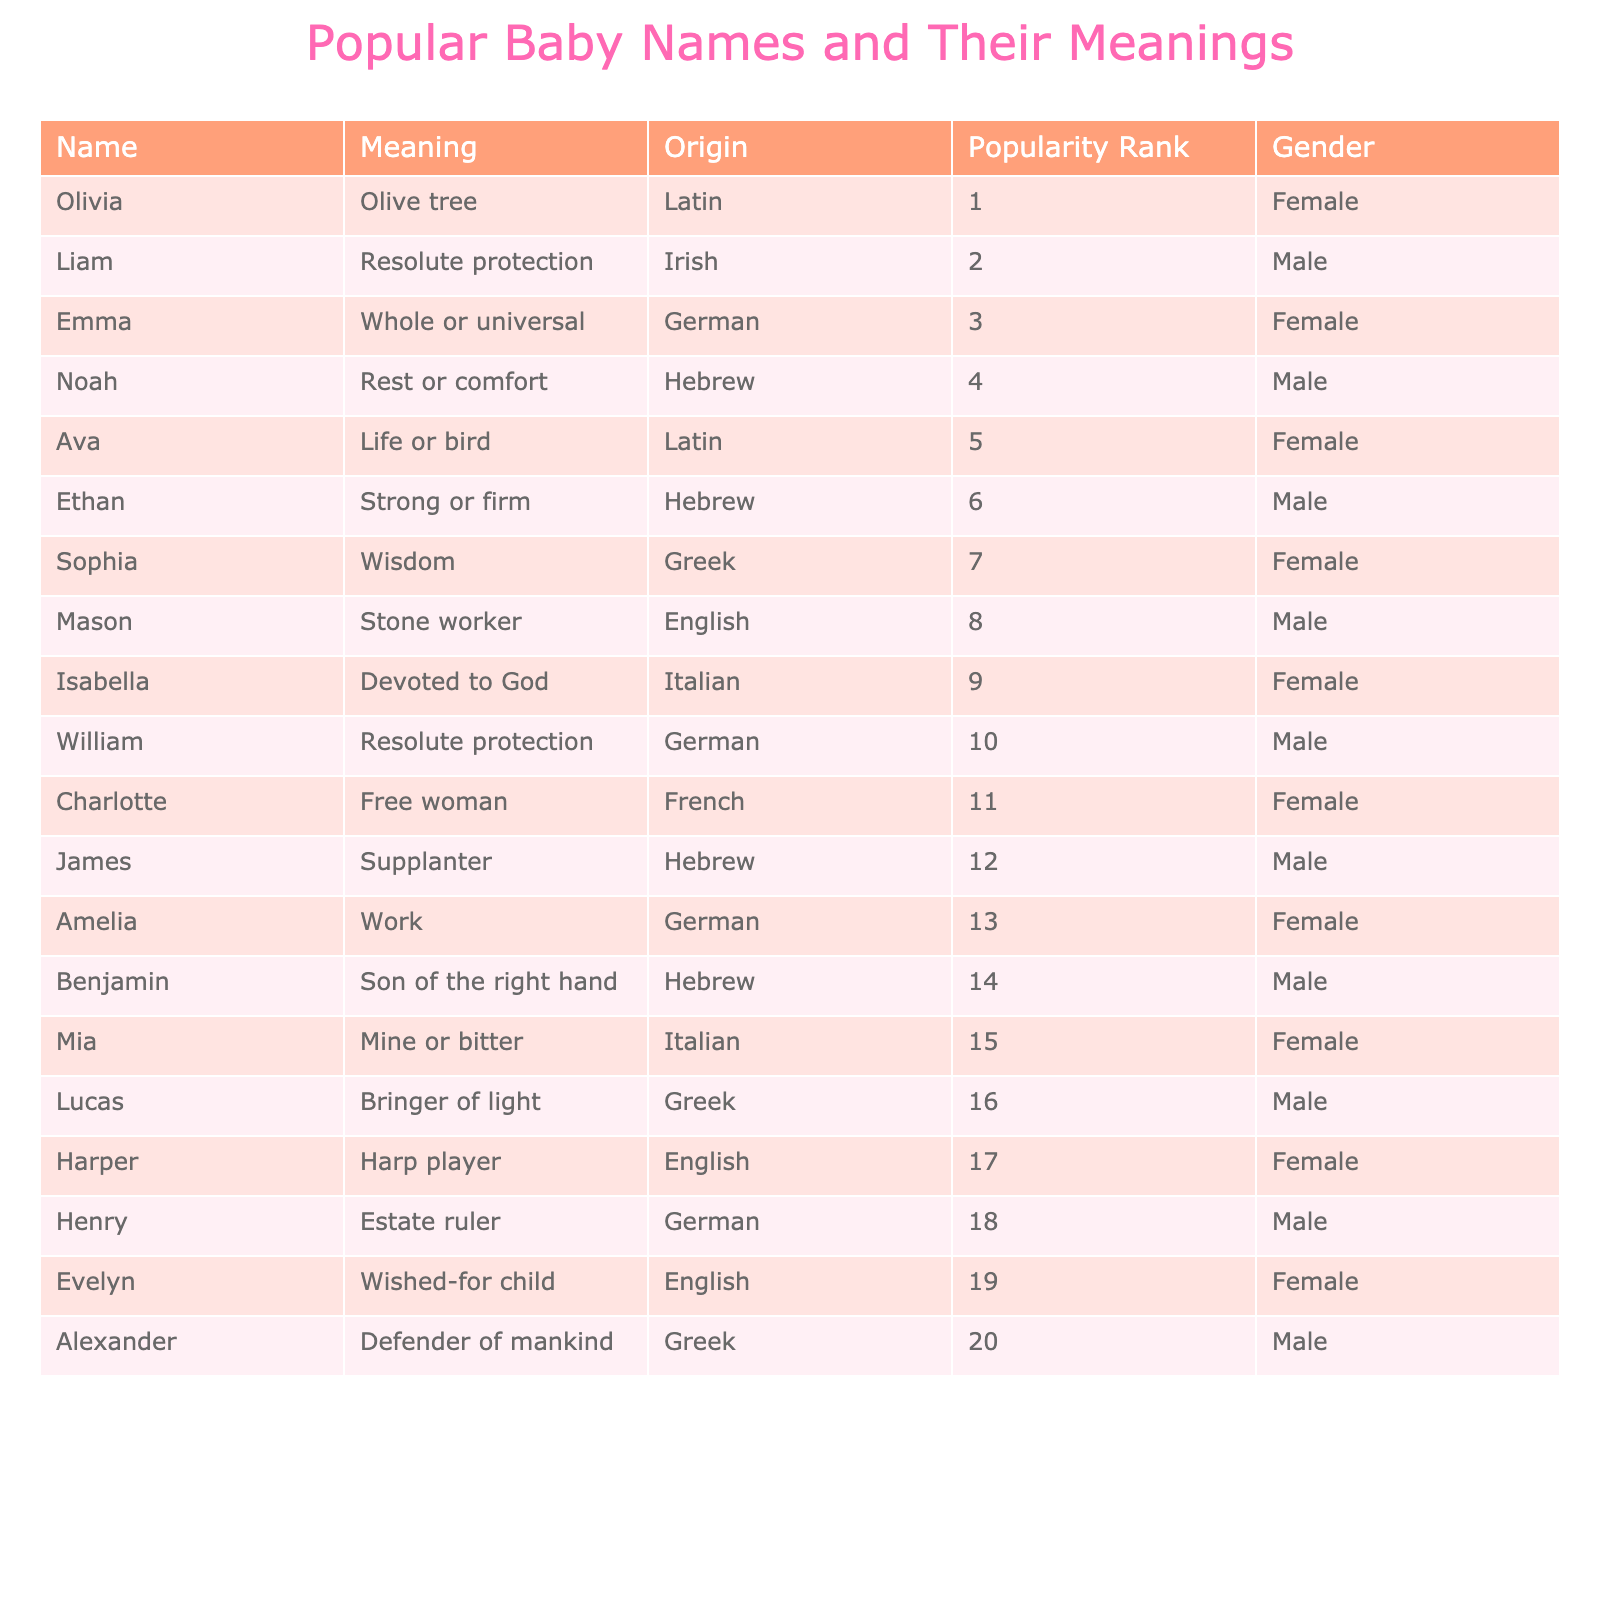What is the most popular baby name for females? The table shows the names and their popularity ranks. Olivia has the rank of 1 and is categorized as female.
Answer: Olivia What name means "rest or comfort"? The table lists the meanings of the names; Noah is associated with "rest or comfort."
Answer: Noah Which name has the origin "Greek" and ranks 20th in popularity? By scanning the table for Greek origins, Alexander is listed and confirmed as rank 20.
Answer: Alexander How many names in the table are listed as male? There are 10 names that are categorized with the male gender according to the table's entries.
Answer: 10 Is Mia ranked higher than Amelia? Checking the popularity ranks, Mia is at rank 15 and Amelia at rank 13, so Amelia is ranked higher than Mia.
Answer: No What is the average popularity rank of the male names listed? The male names' popularity ranks are 2, 4, 6, 8, 10, 12, 14, 16, 18, 20, totaling 10 ranks. The sum is 2 + 4 + 6 + 8 + 10 + 12 + 14 + 16 + 18 + 20 = 118. The average is 118 / 10 = 11.8.
Answer: 11.8 Which name with Latin origin has the meaning "life or bird"? In the table, the name Ava has the specified meaning and is marked as of Latin origin.
Answer: Ava Are there more names for females or males in the table? The table includes 10 female names and 10 male names, indicating an equal count of names by gender.
Answer: Equal What is the total count of names associated with the meaning "defender"? In the table, the only name that relates to the meaning "defender" is Alexander.
Answer: 1 Which is the least popular female name listed in the table? Among the female names, Mia is at rank 15, making it the least popular compared to others listed.
Answer: Mia 